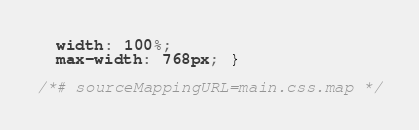<code> <loc_0><loc_0><loc_500><loc_500><_CSS_>  width: 100%;
  max-width: 768px; }

/*# sourceMappingURL=main.css.map */
</code> 